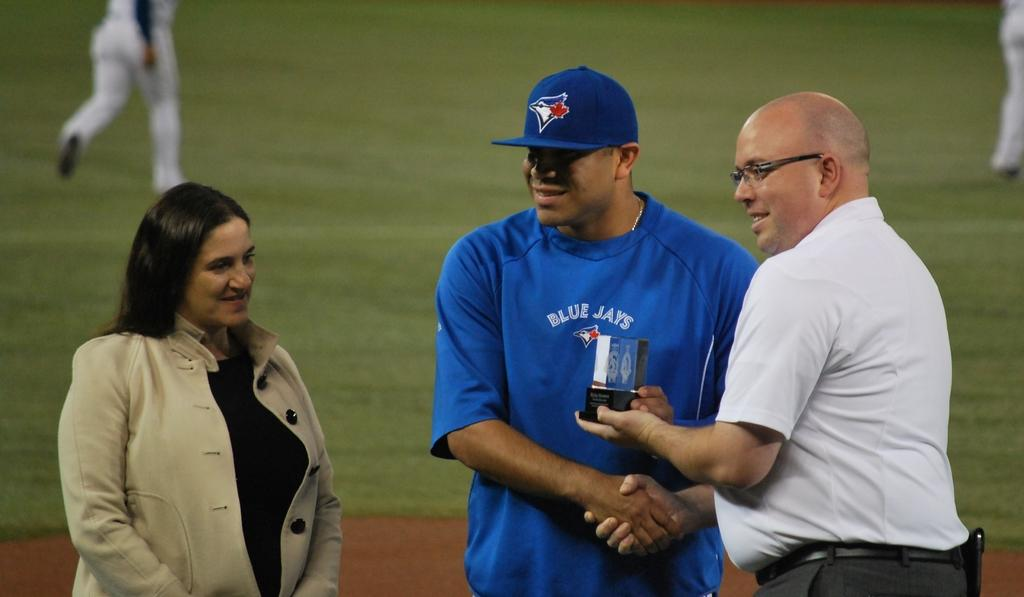<image>
Write a terse but informative summary of the picture. A baseball player with Blue Jays jersey stands between two people. 